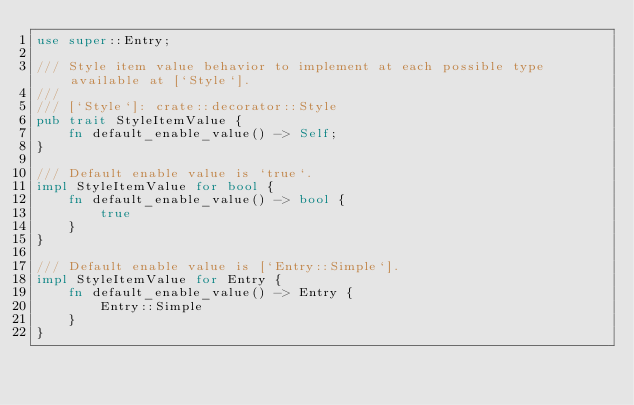<code> <loc_0><loc_0><loc_500><loc_500><_Rust_>use super::Entry;

/// Style item value behavior to implement at each possible type available at [`Style`].
///
/// [`Style`]: crate::decorator::Style
pub trait StyleItemValue {
    fn default_enable_value() -> Self;
}

/// Default enable value is `true`.
impl StyleItemValue for bool {
    fn default_enable_value() -> bool {
        true
    }
}

/// Default enable value is [`Entry::Simple`].
impl StyleItemValue for Entry {
    fn default_enable_value() -> Entry {
        Entry::Simple
    }
}
</code> 